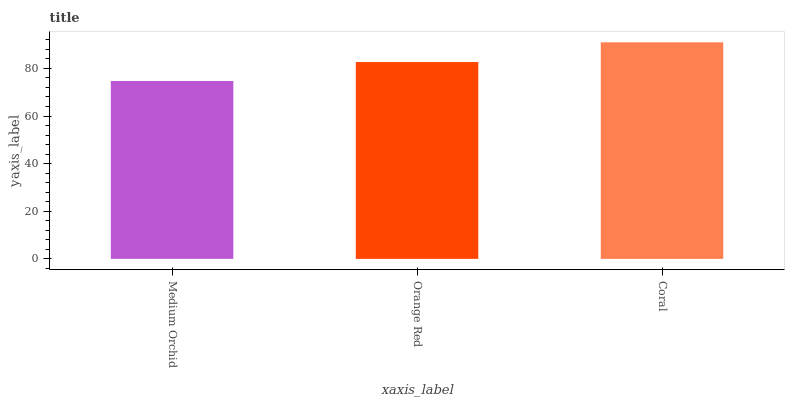Is Medium Orchid the minimum?
Answer yes or no. Yes. Is Coral the maximum?
Answer yes or no. Yes. Is Orange Red the minimum?
Answer yes or no. No. Is Orange Red the maximum?
Answer yes or no. No. Is Orange Red greater than Medium Orchid?
Answer yes or no. Yes. Is Medium Orchid less than Orange Red?
Answer yes or no. Yes. Is Medium Orchid greater than Orange Red?
Answer yes or no. No. Is Orange Red less than Medium Orchid?
Answer yes or no. No. Is Orange Red the high median?
Answer yes or no. Yes. Is Orange Red the low median?
Answer yes or no. Yes. Is Coral the high median?
Answer yes or no. No. Is Coral the low median?
Answer yes or no. No. 